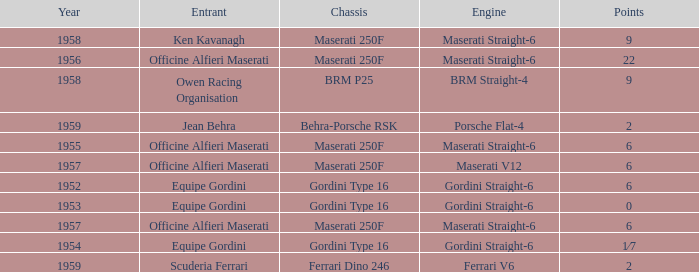What year engine does a ferrari v6 have? 1959.0. 